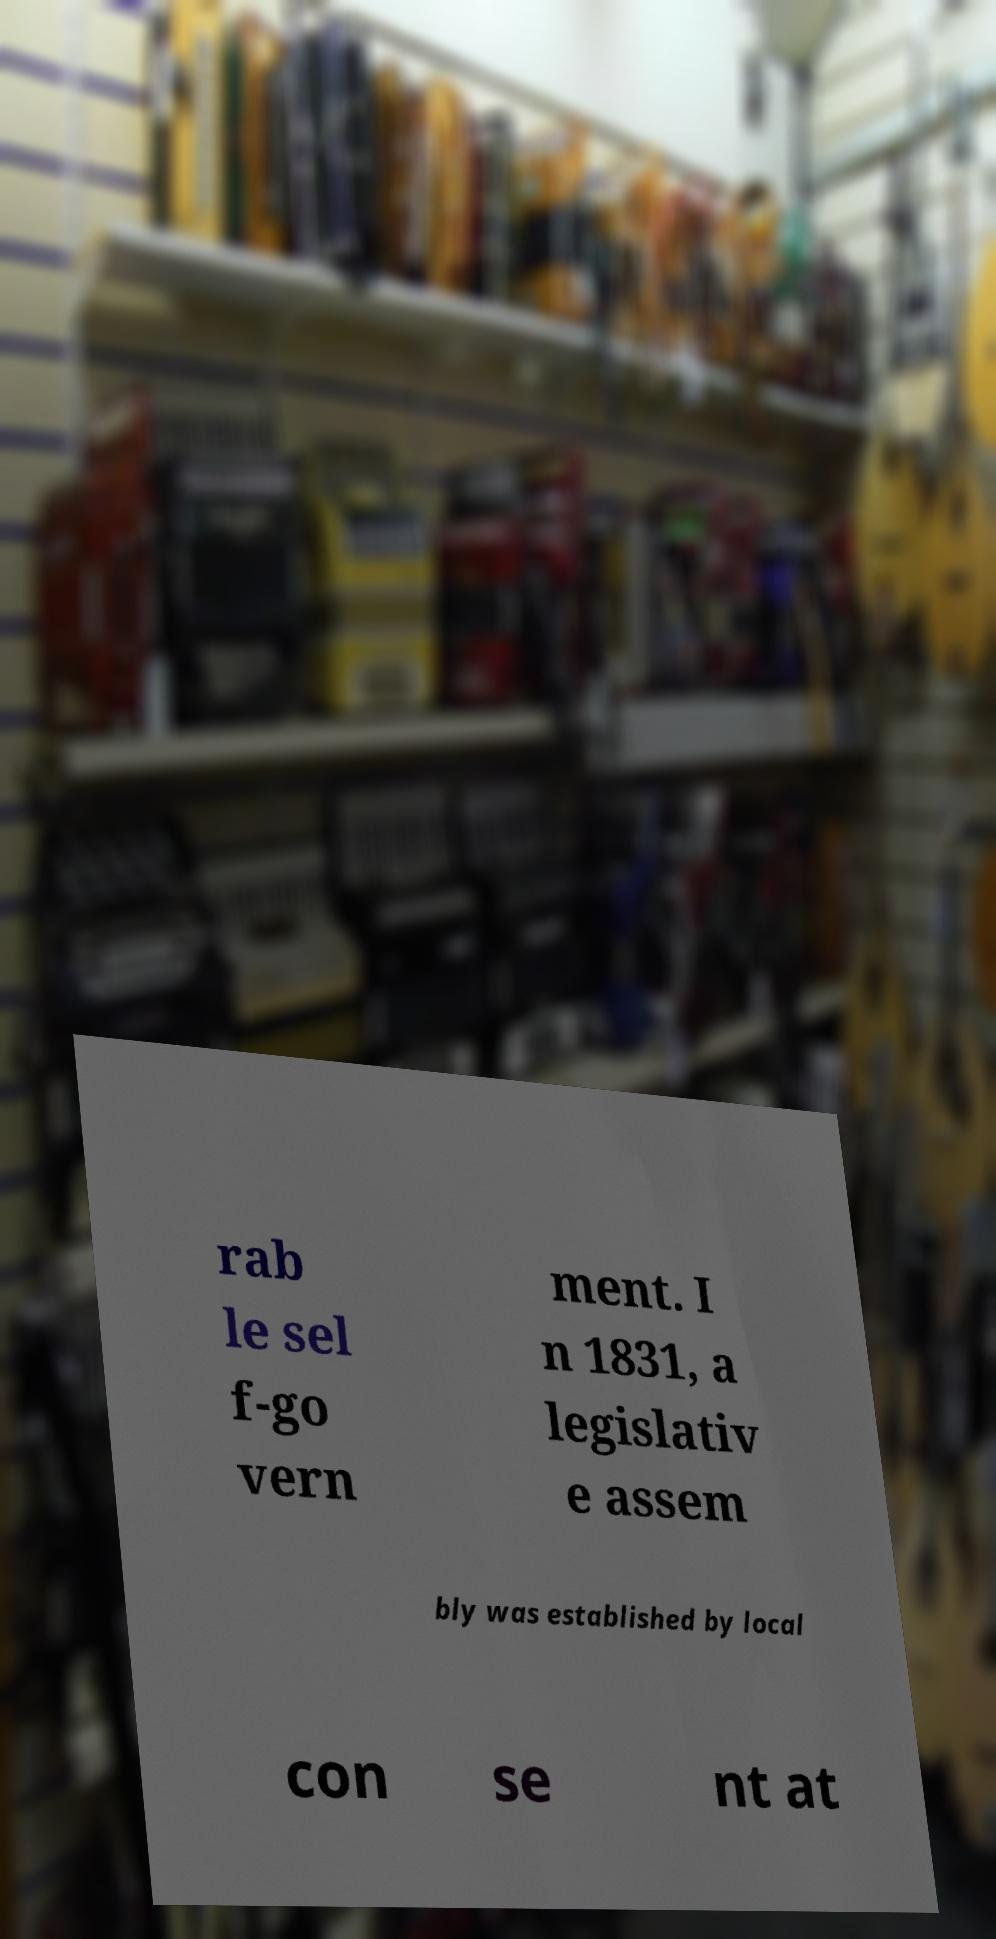There's text embedded in this image that I need extracted. Can you transcribe it verbatim? rab le sel f-go vern ment. I n 1831, a legislativ e assem bly was established by local con se nt at 